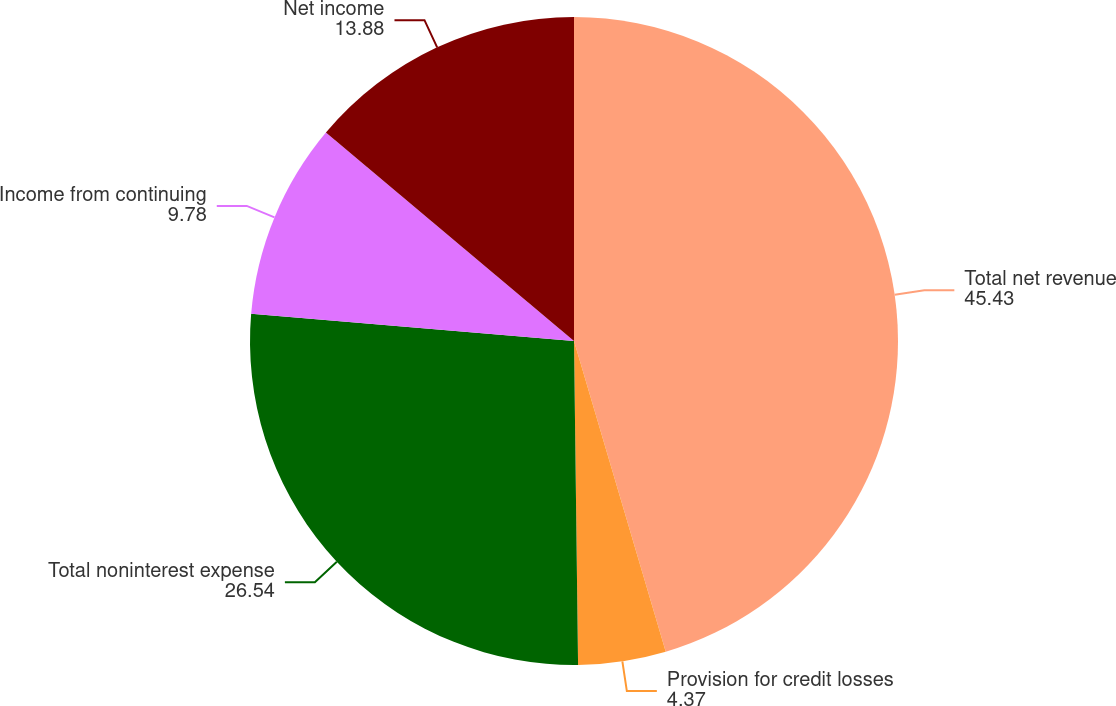Convert chart. <chart><loc_0><loc_0><loc_500><loc_500><pie_chart><fcel>Total net revenue<fcel>Provision for credit losses<fcel>Total noninterest expense<fcel>Income from continuing<fcel>Net income<nl><fcel>45.43%<fcel>4.37%<fcel>26.54%<fcel>9.78%<fcel>13.88%<nl></chart> 